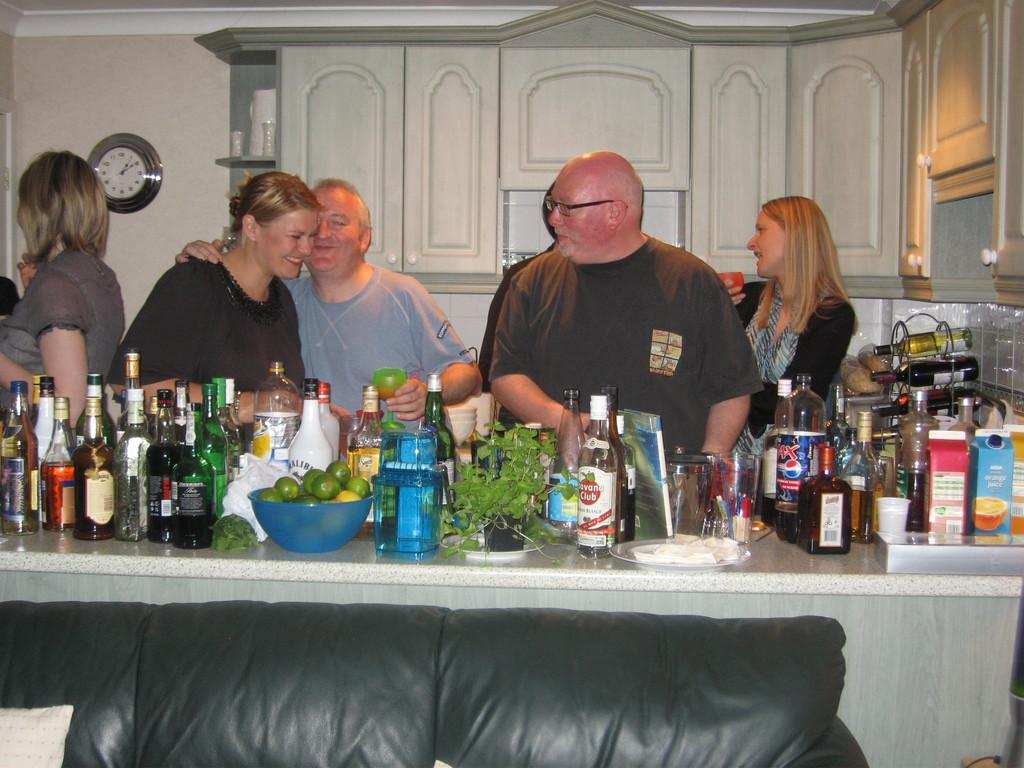Provide a one-sentence caption for the provided image. A party in a residence hase a large spread of drinks and snacks, including Pepsi Max. 